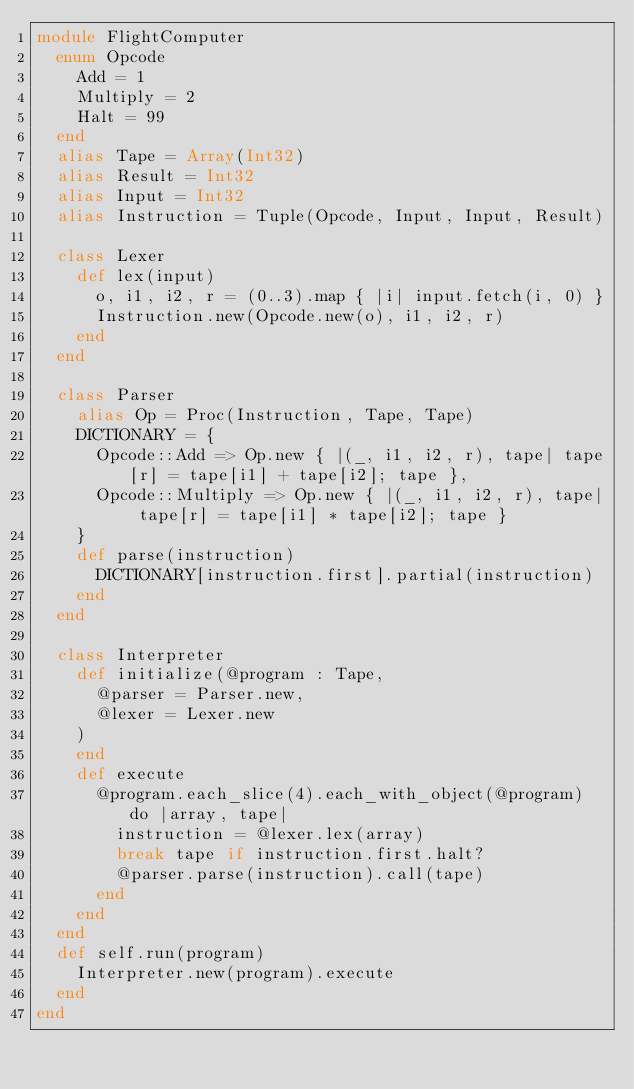Convert code to text. <code><loc_0><loc_0><loc_500><loc_500><_Crystal_>module FlightComputer
  enum Opcode
    Add = 1
    Multiply = 2
    Halt = 99
  end
  alias Tape = Array(Int32)
  alias Result = Int32
  alias Input = Int32
  alias Instruction = Tuple(Opcode, Input, Input, Result)

  class Lexer
    def lex(input)
      o, i1, i2, r = (0..3).map { |i| input.fetch(i, 0) }
      Instruction.new(Opcode.new(o), i1, i2, r)
    end
  end

  class Parser
    alias Op = Proc(Instruction, Tape, Tape)
    DICTIONARY = {
      Opcode::Add => Op.new { |(_, i1, i2, r), tape| tape[r] = tape[i1] + tape[i2]; tape },
      Opcode::Multiply => Op.new { |(_, i1, i2, r), tape| tape[r] = tape[i1] * tape[i2]; tape } 
    }
    def parse(instruction)
      DICTIONARY[instruction.first].partial(instruction)
    end
  end

  class Interpreter
    def initialize(@program : Tape,
      @parser = Parser.new,
      @lexer = Lexer.new
    )
    end
    def execute
      @program.each_slice(4).each_with_object(@program) do |array, tape|
        instruction = @lexer.lex(array)
        break tape if instruction.first.halt?
        @parser.parse(instruction).call(tape)
      end
    end
  end
  def self.run(program)
    Interpreter.new(program).execute
  end
end
</code> 